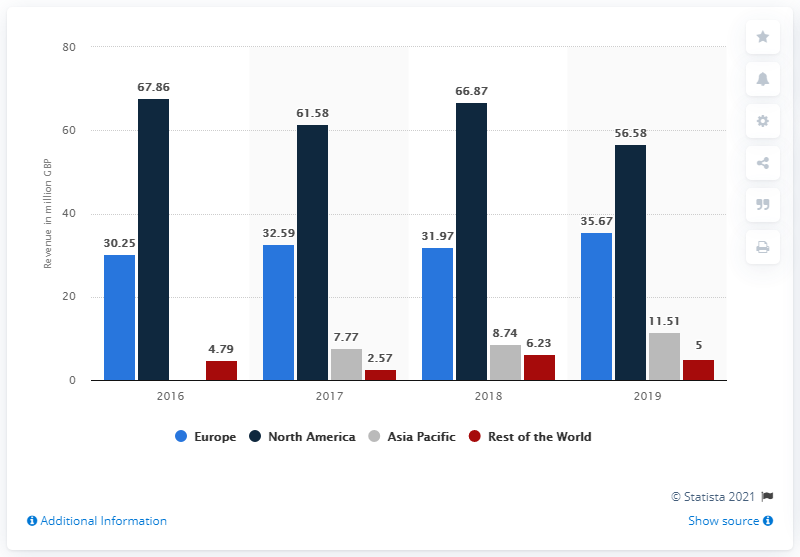Point out several critical features in this image. Hunter Boots generated €35.67 million in revenue in the European market in the same year. The biggest market for the British boots and footwear brand Hunter was North America. Hunter Boots generates the majority of its revenue from the Asia Pacific region. In 2020, the annual revenue of Hunter Boots in North America was $56.58 million. 